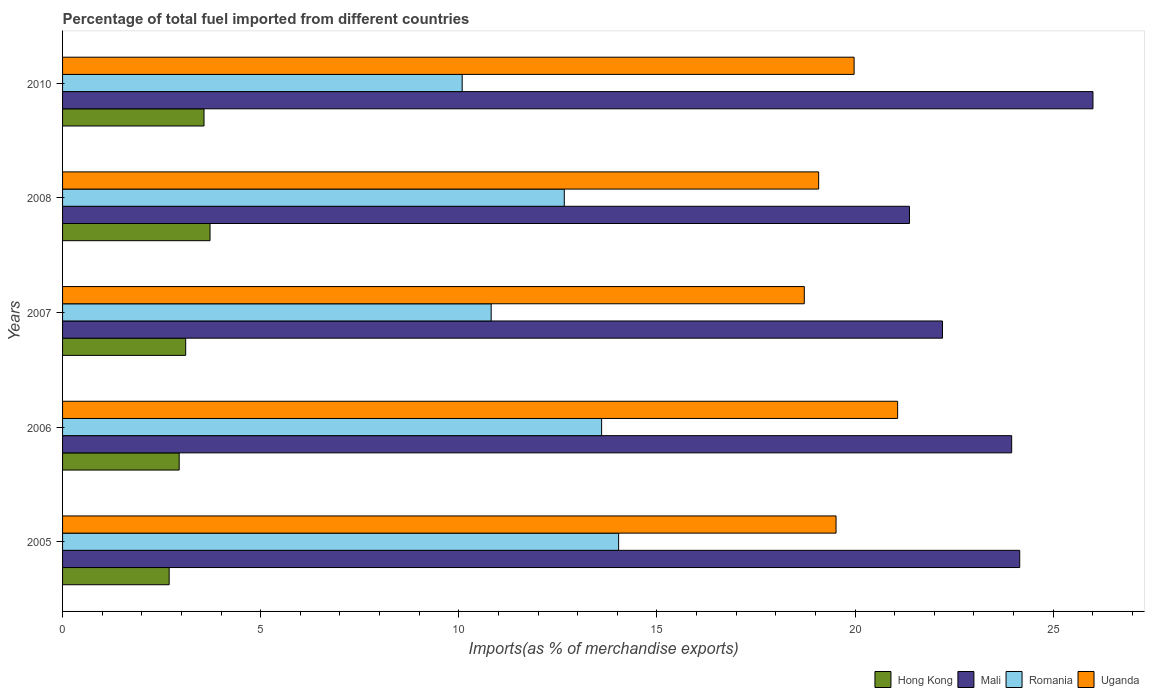How many different coloured bars are there?
Give a very brief answer. 4. Are the number of bars on each tick of the Y-axis equal?
Offer a terse response. Yes. How many bars are there on the 5th tick from the bottom?
Provide a short and direct response. 4. What is the percentage of imports to different countries in Uganda in 2005?
Make the answer very short. 19.52. Across all years, what is the maximum percentage of imports to different countries in Romania?
Your answer should be compact. 14.03. Across all years, what is the minimum percentage of imports to different countries in Romania?
Offer a terse response. 10.09. In which year was the percentage of imports to different countries in Hong Kong minimum?
Offer a terse response. 2005. What is the total percentage of imports to different countries in Uganda in the graph?
Offer a terse response. 98.37. What is the difference between the percentage of imports to different countries in Hong Kong in 2006 and that in 2008?
Your answer should be very brief. -0.78. What is the difference between the percentage of imports to different countries in Hong Kong in 2010 and the percentage of imports to different countries in Mali in 2007?
Keep it short and to the point. -18.64. What is the average percentage of imports to different countries in Uganda per year?
Make the answer very short. 19.67. In the year 2008, what is the difference between the percentage of imports to different countries in Uganda and percentage of imports to different countries in Romania?
Give a very brief answer. 6.42. What is the ratio of the percentage of imports to different countries in Mali in 2007 to that in 2008?
Keep it short and to the point. 1.04. Is the percentage of imports to different countries in Romania in 2008 less than that in 2010?
Offer a very short reply. No. Is the difference between the percentage of imports to different countries in Uganda in 2006 and 2008 greater than the difference between the percentage of imports to different countries in Romania in 2006 and 2008?
Keep it short and to the point. Yes. What is the difference between the highest and the second highest percentage of imports to different countries in Mali?
Provide a short and direct response. 1.85. What is the difference between the highest and the lowest percentage of imports to different countries in Hong Kong?
Offer a very short reply. 1.03. In how many years, is the percentage of imports to different countries in Uganda greater than the average percentage of imports to different countries in Uganda taken over all years?
Make the answer very short. 2. Is the sum of the percentage of imports to different countries in Romania in 2005 and 2010 greater than the maximum percentage of imports to different countries in Uganda across all years?
Your response must be concise. Yes. Is it the case that in every year, the sum of the percentage of imports to different countries in Uganda and percentage of imports to different countries in Mali is greater than the sum of percentage of imports to different countries in Romania and percentage of imports to different countries in Hong Kong?
Your answer should be very brief. Yes. What does the 2nd bar from the top in 2010 represents?
Your response must be concise. Romania. What does the 3rd bar from the bottom in 2005 represents?
Make the answer very short. Romania. Are all the bars in the graph horizontal?
Offer a very short reply. Yes. How many years are there in the graph?
Offer a terse response. 5. What is the difference between two consecutive major ticks on the X-axis?
Offer a very short reply. 5. Are the values on the major ticks of X-axis written in scientific E-notation?
Keep it short and to the point. No. Does the graph contain any zero values?
Provide a succinct answer. No. Does the graph contain grids?
Your answer should be very brief. No. How many legend labels are there?
Offer a very short reply. 4. What is the title of the graph?
Provide a short and direct response. Percentage of total fuel imported from different countries. What is the label or title of the X-axis?
Your answer should be compact. Imports(as % of merchandise exports). What is the Imports(as % of merchandise exports) in Hong Kong in 2005?
Your response must be concise. 2.69. What is the Imports(as % of merchandise exports) of Mali in 2005?
Give a very brief answer. 24.16. What is the Imports(as % of merchandise exports) of Romania in 2005?
Keep it short and to the point. 14.03. What is the Imports(as % of merchandise exports) of Uganda in 2005?
Provide a short and direct response. 19.52. What is the Imports(as % of merchandise exports) of Hong Kong in 2006?
Keep it short and to the point. 2.94. What is the Imports(as % of merchandise exports) in Mali in 2006?
Make the answer very short. 23.95. What is the Imports(as % of merchandise exports) of Romania in 2006?
Your answer should be compact. 13.6. What is the Imports(as % of merchandise exports) in Uganda in 2006?
Offer a terse response. 21.07. What is the Imports(as % of merchandise exports) in Hong Kong in 2007?
Give a very brief answer. 3.11. What is the Imports(as % of merchandise exports) of Mali in 2007?
Your response must be concise. 22.21. What is the Imports(as % of merchandise exports) in Romania in 2007?
Ensure brevity in your answer.  10.82. What is the Imports(as % of merchandise exports) in Uganda in 2007?
Your answer should be compact. 18.72. What is the Imports(as % of merchandise exports) in Hong Kong in 2008?
Your response must be concise. 3.72. What is the Imports(as % of merchandise exports) in Mali in 2008?
Provide a short and direct response. 21.37. What is the Imports(as % of merchandise exports) in Romania in 2008?
Give a very brief answer. 12.66. What is the Imports(as % of merchandise exports) of Uganda in 2008?
Your answer should be compact. 19.08. What is the Imports(as % of merchandise exports) of Hong Kong in 2010?
Give a very brief answer. 3.57. What is the Imports(as % of merchandise exports) of Mali in 2010?
Ensure brevity in your answer.  26. What is the Imports(as % of merchandise exports) in Romania in 2010?
Your response must be concise. 10.09. What is the Imports(as % of merchandise exports) of Uganda in 2010?
Your answer should be compact. 19.98. Across all years, what is the maximum Imports(as % of merchandise exports) of Hong Kong?
Offer a terse response. 3.72. Across all years, what is the maximum Imports(as % of merchandise exports) of Mali?
Ensure brevity in your answer.  26. Across all years, what is the maximum Imports(as % of merchandise exports) of Romania?
Your answer should be very brief. 14.03. Across all years, what is the maximum Imports(as % of merchandise exports) in Uganda?
Offer a terse response. 21.07. Across all years, what is the minimum Imports(as % of merchandise exports) of Hong Kong?
Your answer should be very brief. 2.69. Across all years, what is the minimum Imports(as % of merchandise exports) in Mali?
Your answer should be compact. 21.37. Across all years, what is the minimum Imports(as % of merchandise exports) in Romania?
Ensure brevity in your answer.  10.09. Across all years, what is the minimum Imports(as % of merchandise exports) of Uganda?
Offer a very short reply. 18.72. What is the total Imports(as % of merchandise exports) in Hong Kong in the graph?
Ensure brevity in your answer.  16.03. What is the total Imports(as % of merchandise exports) of Mali in the graph?
Ensure brevity in your answer.  117.69. What is the total Imports(as % of merchandise exports) in Romania in the graph?
Offer a terse response. 61.2. What is the total Imports(as % of merchandise exports) of Uganda in the graph?
Provide a succinct answer. 98.37. What is the difference between the Imports(as % of merchandise exports) in Hong Kong in 2005 and that in 2006?
Your answer should be compact. -0.25. What is the difference between the Imports(as % of merchandise exports) of Mali in 2005 and that in 2006?
Your answer should be very brief. 0.2. What is the difference between the Imports(as % of merchandise exports) in Romania in 2005 and that in 2006?
Your answer should be very brief. 0.43. What is the difference between the Imports(as % of merchandise exports) of Uganda in 2005 and that in 2006?
Provide a succinct answer. -1.55. What is the difference between the Imports(as % of merchandise exports) in Hong Kong in 2005 and that in 2007?
Offer a very short reply. -0.42. What is the difference between the Imports(as % of merchandise exports) in Mali in 2005 and that in 2007?
Ensure brevity in your answer.  1.95. What is the difference between the Imports(as % of merchandise exports) in Romania in 2005 and that in 2007?
Provide a short and direct response. 3.22. What is the difference between the Imports(as % of merchandise exports) of Uganda in 2005 and that in 2007?
Give a very brief answer. 0.8. What is the difference between the Imports(as % of merchandise exports) of Hong Kong in 2005 and that in 2008?
Ensure brevity in your answer.  -1.03. What is the difference between the Imports(as % of merchandise exports) of Mali in 2005 and that in 2008?
Ensure brevity in your answer.  2.78. What is the difference between the Imports(as % of merchandise exports) in Romania in 2005 and that in 2008?
Ensure brevity in your answer.  1.37. What is the difference between the Imports(as % of merchandise exports) of Uganda in 2005 and that in 2008?
Your response must be concise. 0.44. What is the difference between the Imports(as % of merchandise exports) in Hong Kong in 2005 and that in 2010?
Keep it short and to the point. -0.88. What is the difference between the Imports(as % of merchandise exports) of Mali in 2005 and that in 2010?
Give a very brief answer. -1.85. What is the difference between the Imports(as % of merchandise exports) of Romania in 2005 and that in 2010?
Your answer should be compact. 3.95. What is the difference between the Imports(as % of merchandise exports) of Uganda in 2005 and that in 2010?
Make the answer very short. -0.46. What is the difference between the Imports(as % of merchandise exports) in Hong Kong in 2006 and that in 2007?
Provide a short and direct response. -0.16. What is the difference between the Imports(as % of merchandise exports) in Mali in 2006 and that in 2007?
Provide a short and direct response. 1.75. What is the difference between the Imports(as % of merchandise exports) in Romania in 2006 and that in 2007?
Offer a very short reply. 2.79. What is the difference between the Imports(as % of merchandise exports) in Uganda in 2006 and that in 2007?
Give a very brief answer. 2.36. What is the difference between the Imports(as % of merchandise exports) of Hong Kong in 2006 and that in 2008?
Offer a very short reply. -0.78. What is the difference between the Imports(as % of merchandise exports) of Mali in 2006 and that in 2008?
Offer a terse response. 2.58. What is the difference between the Imports(as % of merchandise exports) in Romania in 2006 and that in 2008?
Keep it short and to the point. 0.94. What is the difference between the Imports(as % of merchandise exports) of Uganda in 2006 and that in 2008?
Make the answer very short. 1.99. What is the difference between the Imports(as % of merchandise exports) of Hong Kong in 2006 and that in 2010?
Offer a very short reply. -0.63. What is the difference between the Imports(as % of merchandise exports) of Mali in 2006 and that in 2010?
Your answer should be compact. -2.05. What is the difference between the Imports(as % of merchandise exports) of Romania in 2006 and that in 2010?
Offer a terse response. 3.52. What is the difference between the Imports(as % of merchandise exports) of Uganda in 2006 and that in 2010?
Offer a very short reply. 1.1. What is the difference between the Imports(as % of merchandise exports) in Hong Kong in 2007 and that in 2008?
Keep it short and to the point. -0.61. What is the difference between the Imports(as % of merchandise exports) in Mali in 2007 and that in 2008?
Keep it short and to the point. 0.83. What is the difference between the Imports(as % of merchandise exports) of Romania in 2007 and that in 2008?
Your answer should be compact. -1.85. What is the difference between the Imports(as % of merchandise exports) in Uganda in 2007 and that in 2008?
Provide a succinct answer. -0.36. What is the difference between the Imports(as % of merchandise exports) of Hong Kong in 2007 and that in 2010?
Ensure brevity in your answer.  -0.46. What is the difference between the Imports(as % of merchandise exports) of Mali in 2007 and that in 2010?
Ensure brevity in your answer.  -3.8. What is the difference between the Imports(as % of merchandise exports) in Romania in 2007 and that in 2010?
Provide a succinct answer. 0.73. What is the difference between the Imports(as % of merchandise exports) of Uganda in 2007 and that in 2010?
Offer a very short reply. -1.26. What is the difference between the Imports(as % of merchandise exports) of Hong Kong in 2008 and that in 2010?
Your answer should be very brief. 0.15. What is the difference between the Imports(as % of merchandise exports) of Mali in 2008 and that in 2010?
Your response must be concise. -4.63. What is the difference between the Imports(as % of merchandise exports) of Romania in 2008 and that in 2010?
Keep it short and to the point. 2.58. What is the difference between the Imports(as % of merchandise exports) of Uganda in 2008 and that in 2010?
Give a very brief answer. -0.89. What is the difference between the Imports(as % of merchandise exports) in Hong Kong in 2005 and the Imports(as % of merchandise exports) in Mali in 2006?
Provide a succinct answer. -21.26. What is the difference between the Imports(as % of merchandise exports) in Hong Kong in 2005 and the Imports(as % of merchandise exports) in Romania in 2006?
Give a very brief answer. -10.91. What is the difference between the Imports(as % of merchandise exports) in Hong Kong in 2005 and the Imports(as % of merchandise exports) in Uganda in 2006?
Give a very brief answer. -18.38. What is the difference between the Imports(as % of merchandise exports) in Mali in 2005 and the Imports(as % of merchandise exports) in Romania in 2006?
Your answer should be compact. 10.55. What is the difference between the Imports(as % of merchandise exports) of Mali in 2005 and the Imports(as % of merchandise exports) of Uganda in 2006?
Your answer should be compact. 3.08. What is the difference between the Imports(as % of merchandise exports) in Romania in 2005 and the Imports(as % of merchandise exports) in Uganda in 2006?
Provide a succinct answer. -7.04. What is the difference between the Imports(as % of merchandise exports) of Hong Kong in 2005 and the Imports(as % of merchandise exports) of Mali in 2007?
Make the answer very short. -19.52. What is the difference between the Imports(as % of merchandise exports) in Hong Kong in 2005 and the Imports(as % of merchandise exports) in Romania in 2007?
Your answer should be very brief. -8.13. What is the difference between the Imports(as % of merchandise exports) in Hong Kong in 2005 and the Imports(as % of merchandise exports) in Uganda in 2007?
Make the answer very short. -16.03. What is the difference between the Imports(as % of merchandise exports) in Mali in 2005 and the Imports(as % of merchandise exports) in Romania in 2007?
Your answer should be compact. 13.34. What is the difference between the Imports(as % of merchandise exports) in Mali in 2005 and the Imports(as % of merchandise exports) in Uganda in 2007?
Your answer should be compact. 5.44. What is the difference between the Imports(as % of merchandise exports) of Romania in 2005 and the Imports(as % of merchandise exports) of Uganda in 2007?
Keep it short and to the point. -4.69. What is the difference between the Imports(as % of merchandise exports) of Hong Kong in 2005 and the Imports(as % of merchandise exports) of Mali in 2008?
Keep it short and to the point. -18.68. What is the difference between the Imports(as % of merchandise exports) of Hong Kong in 2005 and the Imports(as % of merchandise exports) of Romania in 2008?
Give a very brief answer. -9.97. What is the difference between the Imports(as % of merchandise exports) of Hong Kong in 2005 and the Imports(as % of merchandise exports) of Uganda in 2008?
Make the answer very short. -16.39. What is the difference between the Imports(as % of merchandise exports) in Mali in 2005 and the Imports(as % of merchandise exports) in Romania in 2008?
Keep it short and to the point. 11.49. What is the difference between the Imports(as % of merchandise exports) of Mali in 2005 and the Imports(as % of merchandise exports) of Uganda in 2008?
Keep it short and to the point. 5.07. What is the difference between the Imports(as % of merchandise exports) of Romania in 2005 and the Imports(as % of merchandise exports) of Uganda in 2008?
Provide a succinct answer. -5.05. What is the difference between the Imports(as % of merchandise exports) in Hong Kong in 2005 and the Imports(as % of merchandise exports) in Mali in 2010?
Provide a succinct answer. -23.31. What is the difference between the Imports(as % of merchandise exports) in Hong Kong in 2005 and the Imports(as % of merchandise exports) in Romania in 2010?
Your answer should be compact. -7.39. What is the difference between the Imports(as % of merchandise exports) in Hong Kong in 2005 and the Imports(as % of merchandise exports) in Uganda in 2010?
Provide a succinct answer. -17.29. What is the difference between the Imports(as % of merchandise exports) in Mali in 2005 and the Imports(as % of merchandise exports) in Romania in 2010?
Your response must be concise. 14.07. What is the difference between the Imports(as % of merchandise exports) in Mali in 2005 and the Imports(as % of merchandise exports) in Uganda in 2010?
Provide a short and direct response. 4.18. What is the difference between the Imports(as % of merchandise exports) in Romania in 2005 and the Imports(as % of merchandise exports) in Uganda in 2010?
Your answer should be very brief. -5.94. What is the difference between the Imports(as % of merchandise exports) in Hong Kong in 2006 and the Imports(as % of merchandise exports) in Mali in 2007?
Your answer should be very brief. -19.26. What is the difference between the Imports(as % of merchandise exports) of Hong Kong in 2006 and the Imports(as % of merchandise exports) of Romania in 2007?
Your answer should be very brief. -7.87. What is the difference between the Imports(as % of merchandise exports) in Hong Kong in 2006 and the Imports(as % of merchandise exports) in Uganda in 2007?
Your answer should be very brief. -15.78. What is the difference between the Imports(as % of merchandise exports) in Mali in 2006 and the Imports(as % of merchandise exports) in Romania in 2007?
Provide a succinct answer. 13.14. What is the difference between the Imports(as % of merchandise exports) in Mali in 2006 and the Imports(as % of merchandise exports) in Uganda in 2007?
Your answer should be compact. 5.23. What is the difference between the Imports(as % of merchandise exports) of Romania in 2006 and the Imports(as % of merchandise exports) of Uganda in 2007?
Provide a short and direct response. -5.11. What is the difference between the Imports(as % of merchandise exports) in Hong Kong in 2006 and the Imports(as % of merchandise exports) in Mali in 2008?
Your answer should be very brief. -18.43. What is the difference between the Imports(as % of merchandise exports) of Hong Kong in 2006 and the Imports(as % of merchandise exports) of Romania in 2008?
Offer a very short reply. -9.72. What is the difference between the Imports(as % of merchandise exports) of Hong Kong in 2006 and the Imports(as % of merchandise exports) of Uganda in 2008?
Make the answer very short. -16.14. What is the difference between the Imports(as % of merchandise exports) of Mali in 2006 and the Imports(as % of merchandise exports) of Romania in 2008?
Make the answer very short. 11.29. What is the difference between the Imports(as % of merchandise exports) of Mali in 2006 and the Imports(as % of merchandise exports) of Uganda in 2008?
Your response must be concise. 4.87. What is the difference between the Imports(as % of merchandise exports) in Romania in 2006 and the Imports(as % of merchandise exports) in Uganda in 2008?
Offer a terse response. -5.48. What is the difference between the Imports(as % of merchandise exports) in Hong Kong in 2006 and the Imports(as % of merchandise exports) in Mali in 2010?
Your response must be concise. -23.06. What is the difference between the Imports(as % of merchandise exports) of Hong Kong in 2006 and the Imports(as % of merchandise exports) of Romania in 2010?
Offer a very short reply. -7.14. What is the difference between the Imports(as % of merchandise exports) in Hong Kong in 2006 and the Imports(as % of merchandise exports) in Uganda in 2010?
Offer a terse response. -17.03. What is the difference between the Imports(as % of merchandise exports) of Mali in 2006 and the Imports(as % of merchandise exports) of Romania in 2010?
Provide a short and direct response. 13.87. What is the difference between the Imports(as % of merchandise exports) of Mali in 2006 and the Imports(as % of merchandise exports) of Uganda in 2010?
Provide a succinct answer. 3.98. What is the difference between the Imports(as % of merchandise exports) in Romania in 2006 and the Imports(as % of merchandise exports) in Uganda in 2010?
Ensure brevity in your answer.  -6.37. What is the difference between the Imports(as % of merchandise exports) of Hong Kong in 2007 and the Imports(as % of merchandise exports) of Mali in 2008?
Make the answer very short. -18.27. What is the difference between the Imports(as % of merchandise exports) in Hong Kong in 2007 and the Imports(as % of merchandise exports) in Romania in 2008?
Offer a very short reply. -9.55. What is the difference between the Imports(as % of merchandise exports) in Hong Kong in 2007 and the Imports(as % of merchandise exports) in Uganda in 2008?
Give a very brief answer. -15.97. What is the difference between the Imports(as % of merchandise exports) of Mali in 2007 and the Imports(as % of merchandise exports) of Romania in 2008?
Provide a short and direct response. 9.54. What is the difference between the Imports(as % of merchandise exports) in Mali in 2007 and the Imports(as % of merchandise exports) in Uganda in 2008?
Offer a very short reply. 3.12. What is the difference between the Imports(as % of merchandise exports) of Romania in 2007 and the Imports(as % of merchandise exports) of Uganda in 2008?
Your response must be concise. -8.26. What is the difference between the Imports(as % of merchandise exports) in Hong Kong in 2007 and the Imports(as % of merchandise exports) in Mali in 2010?
Offer a very short reply. -22.9. What is the difference between the Imports(as % of merchandise exports) of Hong Kong in 2007 and the Imports(as % of merchandise exports) of Romania in 2010?
Your answer should be very brief. -6.98. What is the difference between the Imports(as % of merchandise exports) in Hong Kong in 2007 and the Imports(as % of merchandise exports) in Uganda in 2010?
Provide a short and direct response. -16.87. What is the difference between the Imports(as % of merchandise exports) in Mali in 2007 and the Imports(as % of merchandise exports) in Romania in 2010?
Keep it short and to the point. 12.12. What is the difference between the Imports(as % of merchandise exports) in Mali in 2007 and the Imports(as % of merchandise exports) in Uganda in 2010?
Provide a succinct answer. 2.23. What is the difference between the Imports(as % of merchandise exports) of Romania in 2007 and the Imports(as % of merchandise exports) of Uganda in 2010?
Make the answer very short. -9.16. What is the difference between the Imports(as % of merchandise exports) in Hong Kong in 2008 and the Imports(as % of merchandise exports) in Mali in 2010?
Offer a very short reply. -22.28. What is the difference between the Imports(as % of merchandise exports) in Hong Kong in 2008 and the Imports(as % of merchandise exports) in Romania in 2010?
Your answer should be compact. -6.36. What is the difference between the Imports(as % of merchandise exports) in Hong Kong in 2008 and the Imports(as % of merchandise exports) in Uganda in 2010?
Provide a short and direct response. -16.25. What is the difference between the Imports(as % of merchandise exports) in Mali in 2008 and the Imports(as % of merchandise exports) in Romania in 2010?
Offer a very short reply. 11.29. What is the difference between the Imports(as % of merchandise exports) in Mali in 2008 and the Imports(as % of merchandise exports) in Uganda in 2010?
Offer a terse response. 1.4. What is the difference between the Imports(as % of merchandise exports) of Romania in 2008 and the Imports(as % of merchandise exports) of Uganda in 2010?
Offer a terse response. -7.31. What is the average Imports(as % of merchandise exports) in Hong Kong per year?
Your response must be concise. 3.21. What is the average Imports(as % of merchandise exports) in Mali per year?
Your answer should be compact. 23.54. What is the average Imports(as % of merchandise exports) in Romania per year?
Ensure brevity in your answer.  12.24. What is the average Imports(as % of merchandise exports) of Uganda per year?
Ensure brevity in your answer.  19.67. In the year 2005, what is the difference between the Imports(as % of merchandise exports) in Hong Kong and Imports(as % of merchandise exports) in Mali?
Offer a very short reply. -21.47. In the year 2005, what is the difference between the Imports(as % of merchandise exports) in Hong Kong and Imports(as % of merchandise exports) in Romania?
Your response must be concise. -11.34. In the year 2005, what is the difference between the Imports(as % of merchandise exports) in Hong Kong and Imports(as % of merchandise exports) in Uganda?
Provide a succinct answer. -16.83. In the year 2005, what is the difference between the Imports(as % of merchandise exports) of Mali and Imports(as % of merchandise exports) of Romania?
Keep it short and to the point. 10.12. In the year 2005, what is the difference between the Imports(as % of merchandise exports) in Mali and Imports(as % of merchandise exports) in Uganda?
Provide a short and direct response. 4.64. In the year 2005, what is the difference between the Imports(as % of merchandise exports) of Romania and Imports(as % of merchandise exports) of Uganda?
Your answer should be compact. -5.49. In the year 2006, what is the difference between the Imports(as % of merchandise exports) of Hong Kong and Imports(as % of merchandise exports) of Mali?
Make the answer very short. -21.01. In the year 2006, what is the difference between the Imports(as % of merchandise exports) in Hong Kong and Imports(as % of merchandise exports) in Romania?
Keep it short and to the point. -10.66. In the year 2006, what is the difference between the Imports(as % of merchandise exports) in Hong Kong and Imports(as % of merchandise exports) in Uganda?
Provide a succinct answer. -18.13. In the year 2006, what is the difference between the Imports(as % of merchandise exports) of Mali and Imports(as % of merchandise exports) of Romania?
Offer a terse response. 10.35. In the year 2006, what is the difference between the Imports(as % of merchandise exports) in Mali and Imports(as % of merchandise exports) in Uganda?
Ensure brevity in your answer.  2.88. In the year 2006, what is the difference between the Imports(as % of merchandise exports) of Romania and Imports(as % of merchandise exports) of Uganda?
Your answer should be compact. -7.47. In the year 2007, what is the difference between the Imports(as % of merchandise exports) in Hong Kong and Imports(as % of merchandise exports) in Mali?
Your answer should be very brief. -19.1. In the year 2007, what is the difference between the Imports(as % of merchandise exports) in Hong Kong and Imports(as % of merchandise exports) in Romania?
Provide a succinct answer. -7.71. In the year 2007, what is the difference between the Imports(as % of merchandise exports) of Hong Kong and Imports(as % of merchandise exports) of Uganda?
Your response must be concise. -15.61. In the year 2007, what is the difference between the Imports(as % of merchandise exports) of Mali and Imports(as % of merchandise exports) of Romania?
Keep it short and to the point. 11.39. In the year 2007, what is the difference between the Imports(as % of merchandise exports) of Mali and Imports(as % of merchandise exports) of Uganda?
Give a very brief answer. 3.49. In the year 2007, what is the difference between the Imports(as % of merchandise exports) in Romania and Imports(as % of merchandise exports) in Uganda?
Keep it short and to the point. -7.9. In the year 2008, what is the difference between the Imports(as % of merchandise exports) of Hong Kong and Imports(as % of merchandise exports) of Mali?
Provide a succinct answer. -17.65. In the year 2008, what is the difference between the Imports(as % of merchandise exports) in Hong Kong and Imports(as % of merchandise exports) in Romania?
Your answer should be compact. -8.94. In the year 2008, what is the difference between the Imports(as % of merchandise exports) of Hong Kong and Imports(as % of merchandise exports) of Uganda?
Your answer should be very brief. -15.36. In the year 2008, what is the difference between the Imports(as % of merchandise exports) in Mali and Imports(as % of merchandise exports) in Romania?
Give a very brief answer. 8.71. In the year 2008, what is the difference between the Imports(as % of merchandise exports) of Mali and Imports(as % of merchandise exports) of Uganda?
Your response must be concise. 2.29. In the year 2008, what is the difference between the Imports(as % of merchandise exports) in Romania and Imports(as % of merchandise exports) in Uganda?
Your answer should be compact. -6.42. In the year 2010, what is the difference between the Imports(as % of merchandise exports) in Hong Kong and Imports(as % of merchandise exports) in Mali?
Provide a succinct answer. -22.43. In the year 2010, what is the difference between the Imports(as % of merchandise exports) in Hong Kong and Imports(as % of merchandise exports) in Romania?
Your answer should be compact. -6.52. In the year 2010, what is the difference between the Imports(as % of merchandise exports) of Hong Kong and Imports(as % of merchandise exports) of Uganda?
Offer a terse response. -16.41. In the year 2010, what is the difference between the Imports(as % of merchandise exports) of Mali and Imports(as % of merchandise exports) of Romania?
Keep it short and to the point. 15.92. In the year 2010, what is the difference between the Imports(as % of merchandise exports) of Mali and Imports(as % of merchandise exports) of Uganda?
Offer a terse response. 6.03. In the year 2010, what is the difference between the Imports(as % of merchandise exports) of Romania and Imports(as % of merchandise exports) of Uganda?
Ensure brevity in your answer.  -9.89. What is the ratio of the Imports(as % of merchandise exports) of Hong Kong in 2005 to that in 2006?
Ensure brevity in your answer.  0.91. What is the ratio of the Imports(as % of merchandise exports) in Mali in 2005 to that in 2006?
Offer a terse response. 1.01. What is the ratio of the Imports(as % of merchandise exports) of Romania in 2005 to that in 2006?
Offer a very short reply. 1.03. What is the ratio of the Imports(as % of merchandise exports) in Uganda in 2005 to that in 2006?
Give a very brief answer. 0.93. What is the ratio of the Imports(as % of merchandise exports) in Hong Kong in 2005 to that in 2007?
Ensure brevity in your answer.  0.87. What is the ratio of the Imports(as % of merchandise exports) in Mali in 2005 to that in 2007?
Give a very brief answer. 1.09. What is the ratio of the Imports(as % of merchandise exports) in Romania in 2005 to that in 2007?
Provide a succinct answer. 1.3. What is the ratio of the Imports(as % of merchandise exports) of Uganda in 2005 to that in 2007?
Your response must be concise. 1.04. What is the ratio of the Imports(as % of merchandise exports) of Hong Kong in 2005 to that in 2008?
Keep it short and to the point. 0.72. What is the ratio of the Imports(as % of merchandise exports) of Mali in 2005 to that in 2008?
Offer a very short reply. 1.13. What is the ratio of the Imports(as % of merchandise exports) of Romania in 2005 to that in 2008?
Provide a succinct answer. 1.11. What is the ratio of the Imports(as % of merchandise exports) of Hong Kong in 2005 to that in 2010?
Give a very brief answer. 0.75. What is the ratio of the Imports(as % of merchandise exports) in Mali in 2005 to that in 2010?
Provide a short and direct response. 0.93. What is the ratio of the Imports(as % of merchandise exports) of Romania in 2005 to that in 2010?
Your answer should be compact. 1.39. What is the ratio of the Imports(as % of merchandise exports) in Uganda in 2005 to that in 2010?
Your answer should be very brief. 0.98. What is the ratio of the Imports(as % of merchandise exports) in Hong Kong in 2006 to that in 2007?
Offer a very short reply. 0.95. What is the ratio of the Imports(as % of merchandise exports) in Mali in 2006 to that in 2007?
Ensure brevity in your answer.  1.08. What is the ratio of the Imports(as % of merchandise exports) in Romania in 2006 to that in 2007?
Make the answer very short. 1.26. What is the ratio of the Imports(as % of merchandise exports) of Uganda in 2006 to that in 2007?
Offer a very short reply. 1.13. What is the ratio of the Imports(as % of merchandise exports) in Hong Kong in 2006 to that in 2008?
Provide a short and direct response. 0.79. What is the ratio of the Imports(as % of merchandise exports) of Mali in 2006 to that in 2008?
Keep it short and to the point. 1.12. What is the ratio of the Imports(as % of merchandise exports) of Romania in 2006 to that in 2008?
Your answer should be very brief. 1.07. What is the ratio of the Imports(as % of merchandise exports) of Uganda in 2006 to that in 2008?
Give a very brief answer. 1.1. What is the ratio of the Imports(as % of merchandise exports) of Hong Kong in 2006 to that in 2010?
Provide a short and direct response. 0.82. What is the ratio of the Imports(as % of merchandise exports) of Mali in 2006 to that in 2010?
Offer a very short reply. 0.92. What is the ratio of the Imports(as % of merchandise exports) of Romania in 2006 to that in 2010?
Offer a very short reply. 1.35. What is the ratio of the Imports(as % of merchandise exports) of Uganda in 2006 to that in 2010?
Provide a short and direct response. 1.05. What is the ratio of the Imports(as % of merchandise exports) in Hong Kong in 2007 to that in 2008?
Your response must be concise. 0.83. What is the ratio of the Imports(as % of merchandise exports) in Mali in 2007 to that in 2008?
Provide a succinct answer. 1.04. What is the ratio of the Imports(as % of merchandise exports) in Romania in 2007 to that in 2008?
Keep it short and to the point. 0.85. What is the ratio of the Imports(as % of merchandise exports) in Uganda in 2007 to that in 2008?
Offer a terse response. 0.98. What is the ratio of the Imports(as % of merchandise exports) of Hong Kong in 2007 to that in 2010?
Your answer should be compact. 0.87. What is the ratio of the Imports(as % of merchandise exports) in Mali in 2007 to that in 2010?
Provide a succinct answer. 0.85. What is the ratio of the Imports(as % of merchandise exports) of Romania in 2007 to that in 2010?
Provide a short and direct response. 1.07. What is the ratio of the Imports(as % of merchandise exports) of Uganda in 2007 to that in 2010?
Provide a short and direct response. 0.94. What is the ratio of the Imports(as % of merchandise exports) in Hong Kong in 2008 to that in 2010?
Offer a very short reply. 1.04. What is the ratio of the Imports(as % of merchandise exports) of Mali in 2008 to that in 2010?
Ensure brevity in your answer.  0.82. What is the ratio of the Imports(as % of merchandise exports) in Romania in 2008 to that in 2010?
Your answer should be very brief. 1.26. What is the ratio of the Imports(as % of merchandise exports) of Uganda in 2008 to that in 2010?
Give a very brief answer. 0.96. What is the difference between the highest and the second highest Imports(as % of merchandise exports) in Hong Kong?
Your response must be concise. 0.15. What is the difference between the highest and the second highest Imports(as % of merchandise exports) in Mali?
Your answer should be compact. 1.85. What is the difference between the highest and the second highest Imports(as % of merchandise exports) in Romania?
Your answer should be compact. 0.43. What is the difference between the highest and the second highest Imports(as % of merchandise exports) of Uganda?
Your answer should be very brief. 1.1. What is the difference between the highest and the lowest Imports(as % of merchandise exports) of Hong Kong?
Give a very brief answer. 1.03. What is the difference between the highest and the lowest Imports(as % of merchandise exports) in Mali?
Keep it short and to the point. 4.63. What is the difference between the highest and the lowest Imports(as % of merchandise exports) in Romania?
Keep it short and to the point. 3.95. What is the difference between the highest and the lowest Imports(as % of merchandise exports) in Uganda?
Provide a succinct answer. 2.36. 